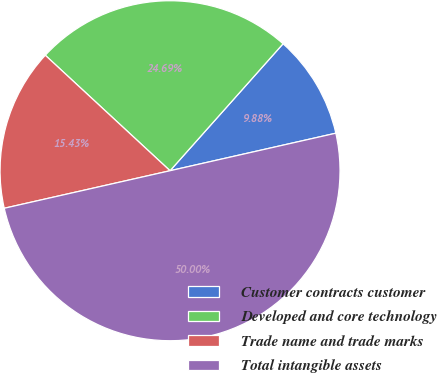Convert chart to OTSL. <chart><loc_0><loc_0><loc_500><loc_500><pie_chart><fcel>Customer contracts customer<fcel>Developed and core technology<fcel>Trade name and trade marks<fcel>Total intangible assets<nl><fcel>9.88%<fcel>24.69%<fcel>15.43%<fcel>50.0%<nl></chart> 